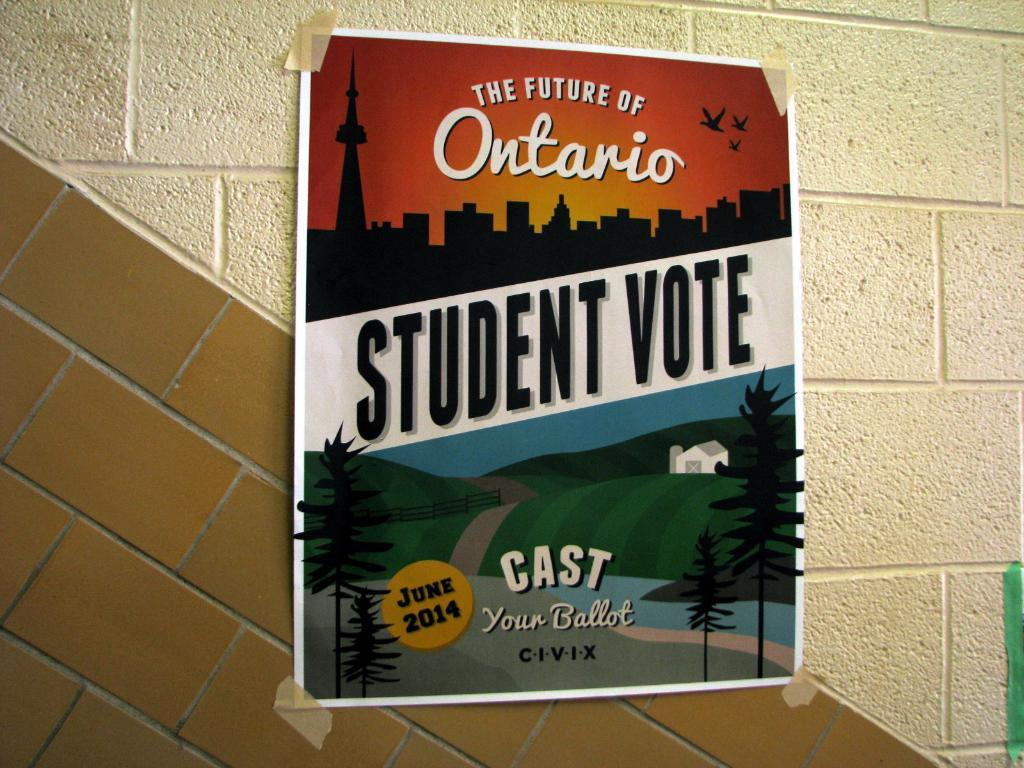What is the main subject in the middle of the image? There is a poster in the middle of the image. What can be seen on the poster? The poster has two images and text. Where is the poster located? The poster is on a wall. What is the appearance of the wall? The wall has two colors. What type of curve can be seen on the stage in the image? There is no stage present in the image, and therefore no curve can be observed. 